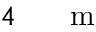Convert formula to latex. <formula><loc_0><loc_0><loc_500><loc_500>4 { { \, } } { m }</formula> 